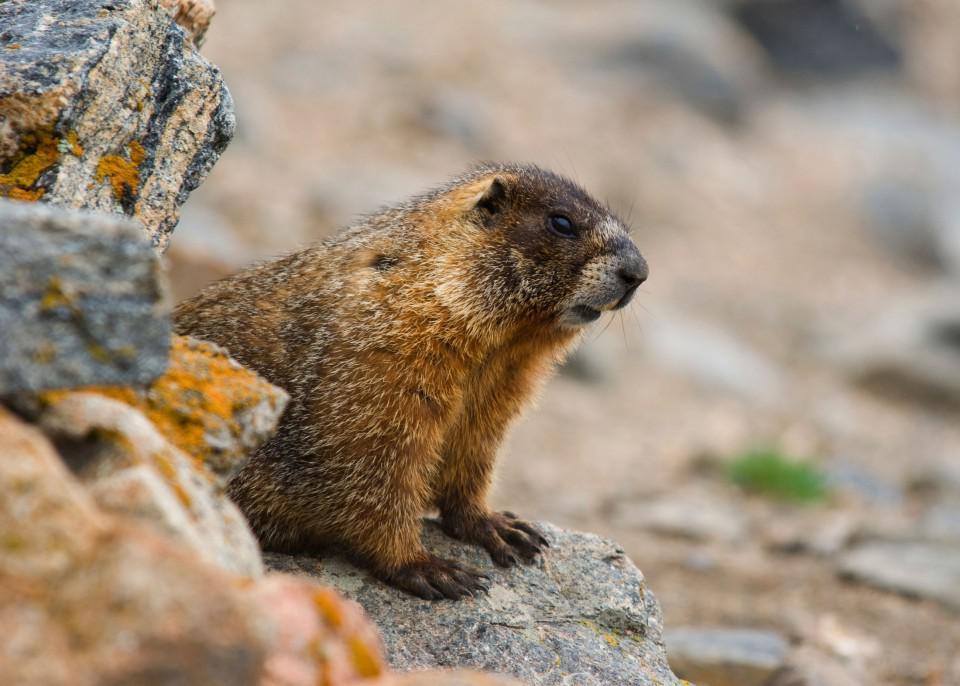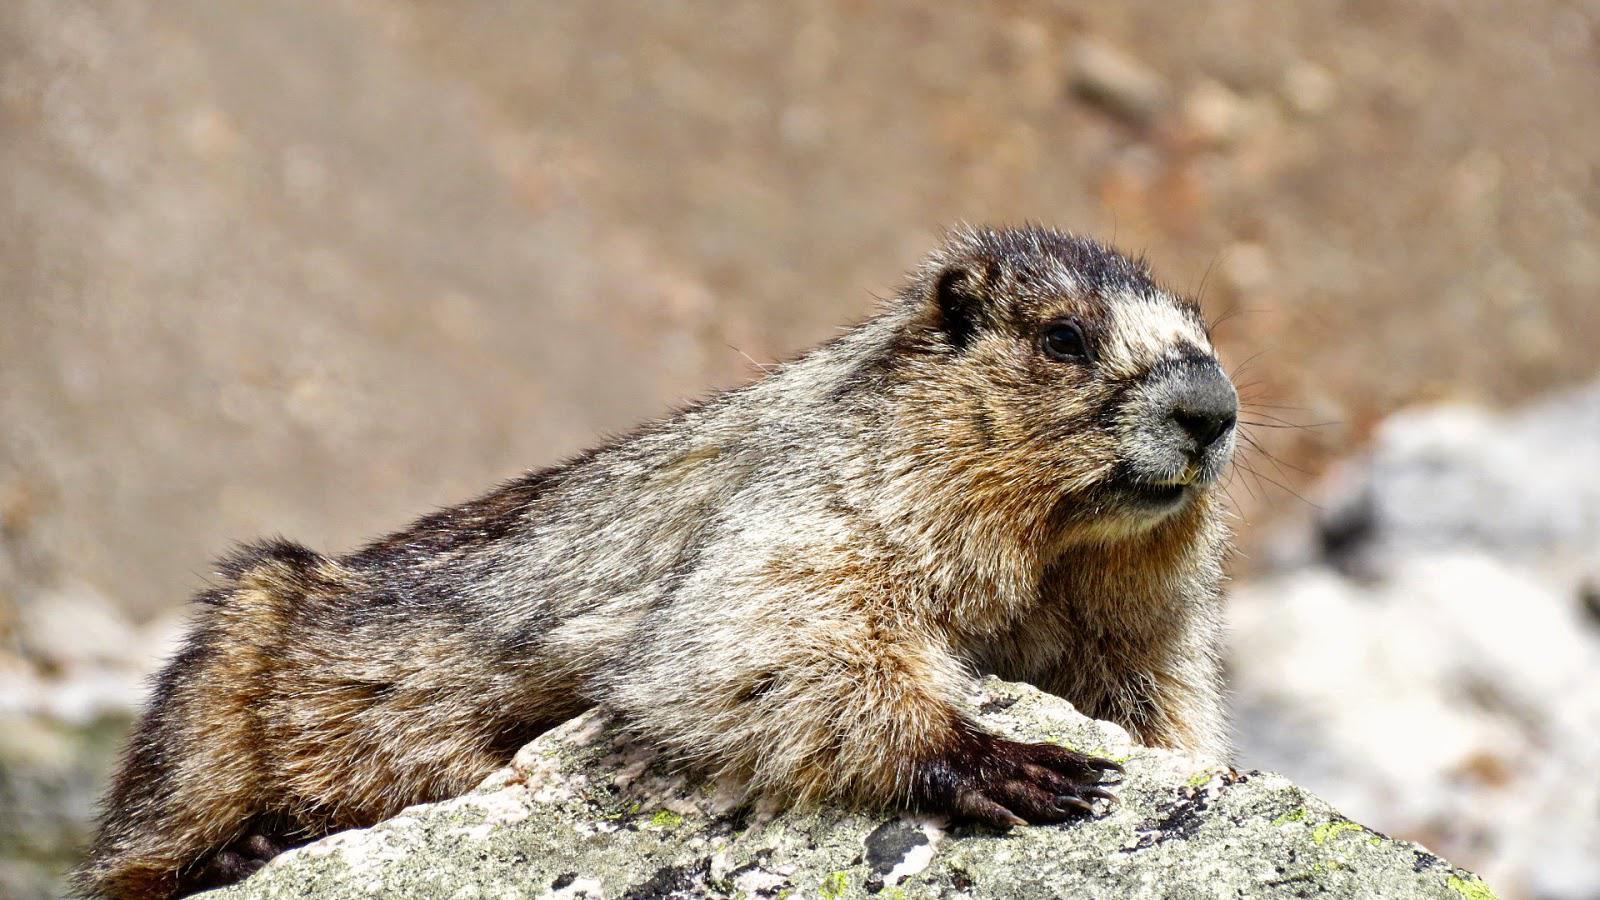The first image is the image on the left, the second image is the image on the right. Assess this claim about the two images: "the animal on the right image is facing left". Correct or not? Answer yes or no. No. 